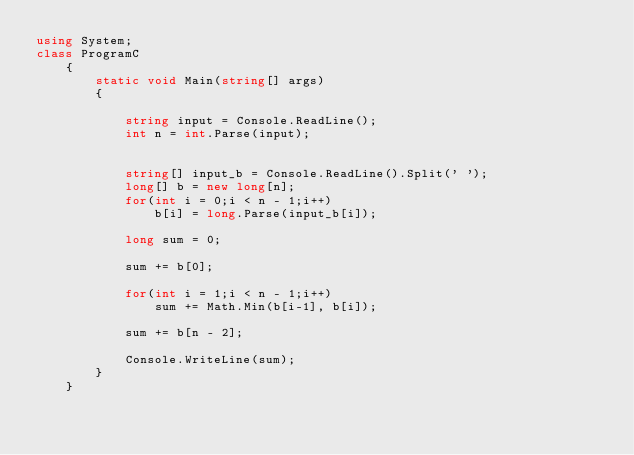<code> <loc_0><loc_0><loc_500><loc_500><_C#_>using System;
class ProgramC
    {
        static void Main(string[] args)
        {
            
            string input = Console.ReadLine();
            int n = int.Parse(input);

            
            string[] input_b = Console.ReadLine().Split(' ');
            long[] b = new long[n];
            for(int i = 0;i < n - 1;i++)
                b[i] = long.Parse(input_b[i]);
            
            long sum = 0;

            sum += b[0];

            for(int i = 1;i < n - 1;i++)
                sum += Math.Min(b[i-1], b[i]);

            sum += b[n - 2];

            Console.WriteLine(sum);
        }
    }</code> 